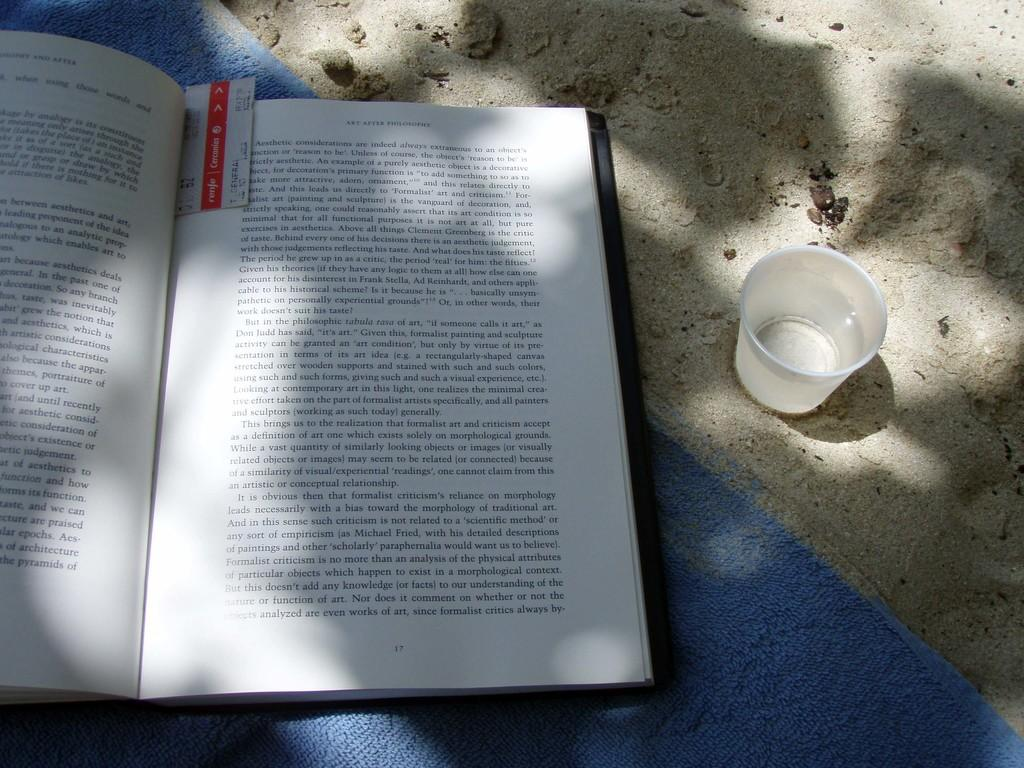Provide a one-sentence caption for the provided image. A book that is open to page 17 and has a bookmark in it. 